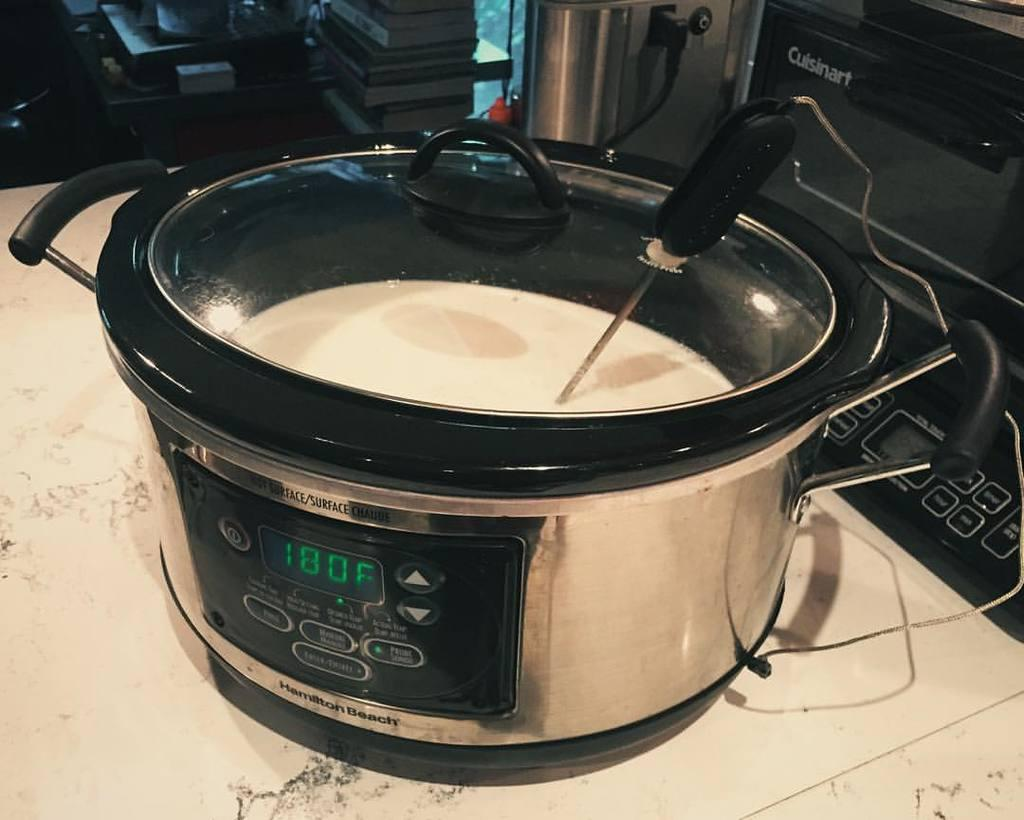<image>
Summarize the visual content of the image. pressure cooker set to 180 degrees with soup in it. 